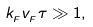<formula> <loc_0><loc_0><loc_500><loc_500>k _ { _ { F } } v _ { _ { F } } \tau \gg 1 ,</formula> 